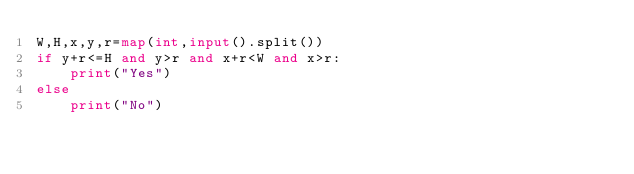Convert code to text. <code><loc_0><loc_0><loc_500><loc_500><_Python_>W,H,x,y,r=map(int,input().split())
if y+r<=H and y>r and x+r<W and x>r:
    print("Yes")
else
    print("No")
</code> 